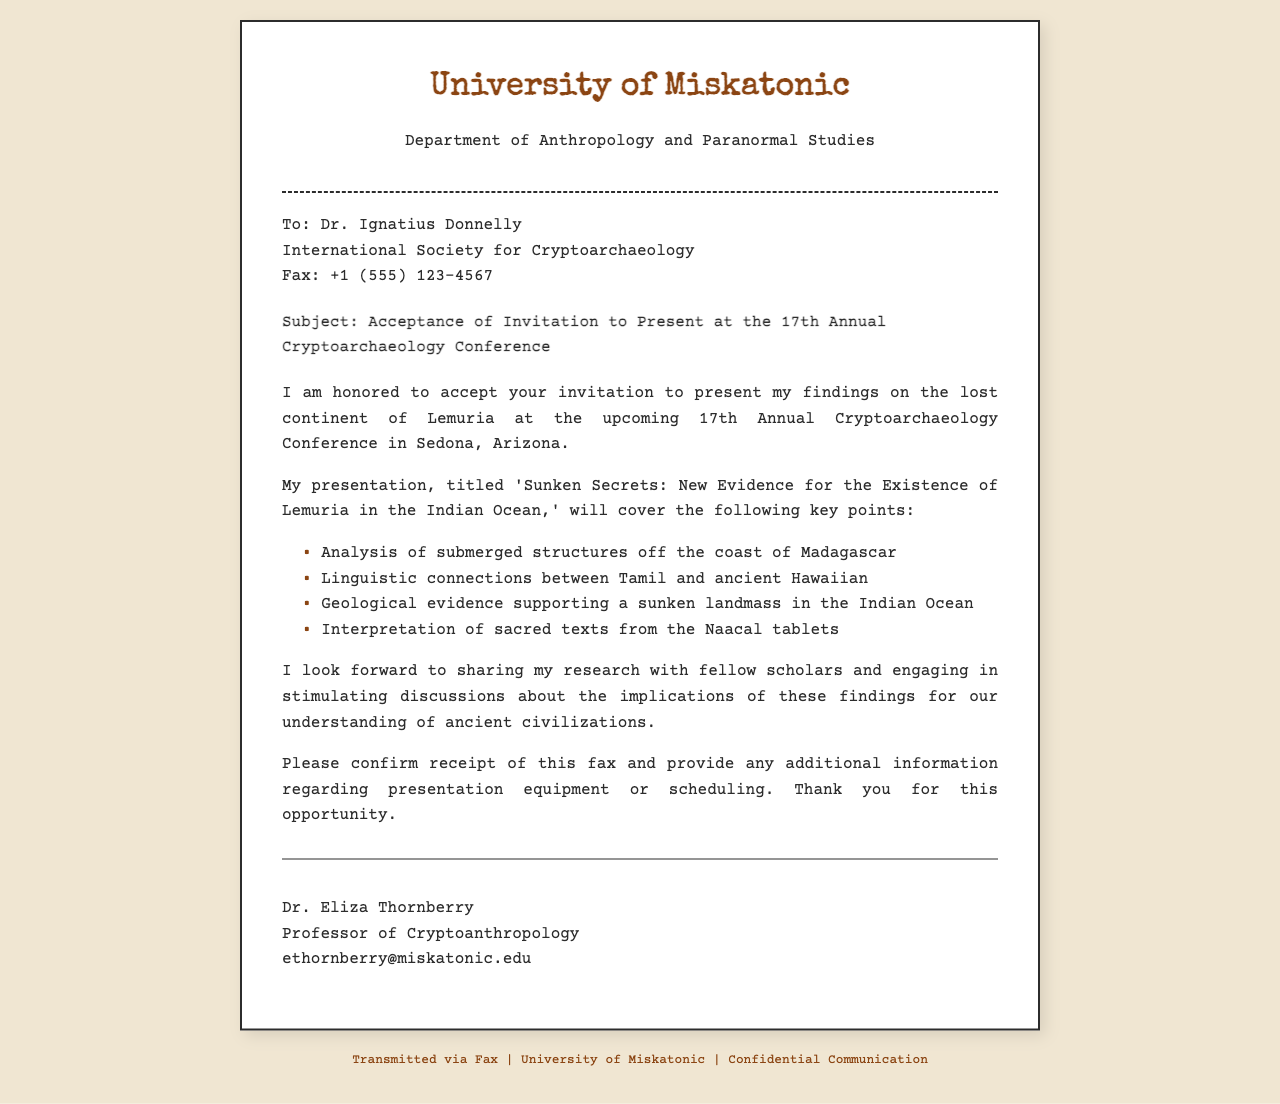What is the title of the presentation? The title of the presentation is mentioned in the document, which is 'Sunken Secrets: New Evidence for the Existence of Lemuria in the Indian Ocean.'
Answer: Sunken Secrets: New Evidence for the Existence of Lemuria in the Indian Ocean Who is the recipient of the fax? The recipient of the fax is identified in the document as Dr. Ignatius Donnelly.
Answer: Dr. Ignatius Donnelly What is the date of the conference? The document specifies that the conference is the 17th Annual Cryptoarchaeology Conference but does not provide a specific date, so the answer reflects the event's designation.
Answer: 17th Annual Cryptoarchaeology Conference What location is the conference being held? The location of the conference is stated in the document as Sedona, Arizona.
Answer: Sedona, Arizona What is one key point mentioned in the presentation? The document outlines several key points of the presentation, including the analysis of submerged structures off the coast of Madagascar.
Answer: Analysis of submerged structures off the coast of Madagascar What is Dr. Eliza Thornberry's title? Dr. Eliza Thornberry's title is listed in the document as Professor of Cryptoanthropology.
Answer: Professor of Cryptoanthropology What does the sender request confirmation of? The sender requests confirmation of receipt of the fax in the document.
Answer: Receipt of this fax Which institution is Dr. Eliza Thornberry affiliated with? The document states that Dr. Eliza Thornberry is affiliated with the University of Miskatonic.
Answer: University of Miskatonic What kind of texts does the presentation interpret? The presentation interprets sacred texts from the Naacal tablets, as mentioned in the document.
Answer: Naacal tablets 